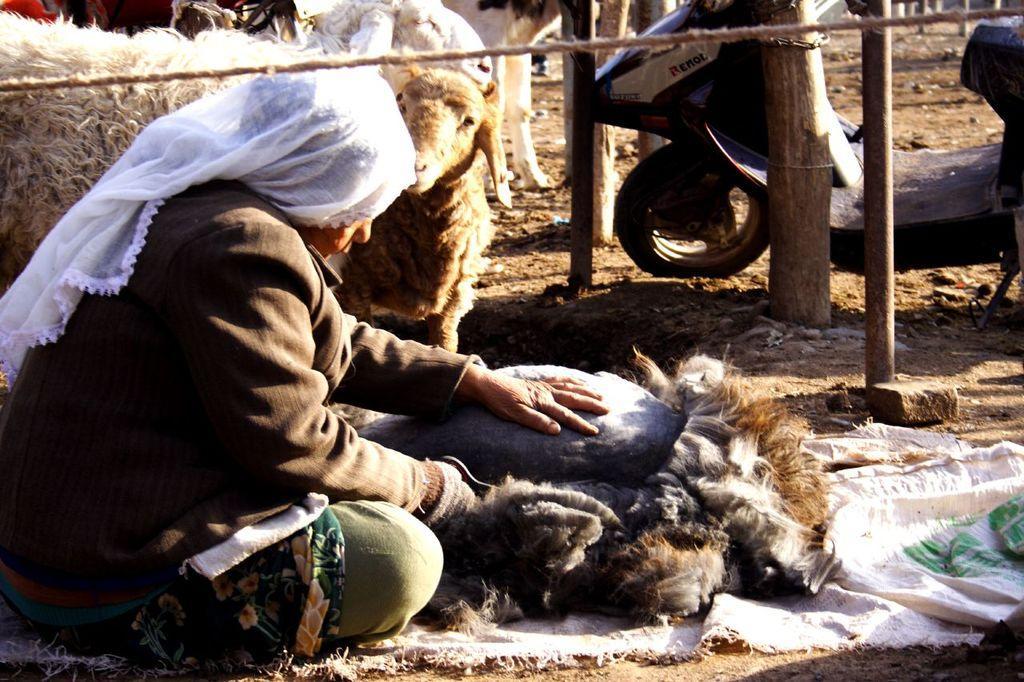Please provide a concise description of this image. In the image we can see a person sitting and wearing clothes. We can even see a two wheeler and there are animals. Here we can see the rope, pole and the sand. 